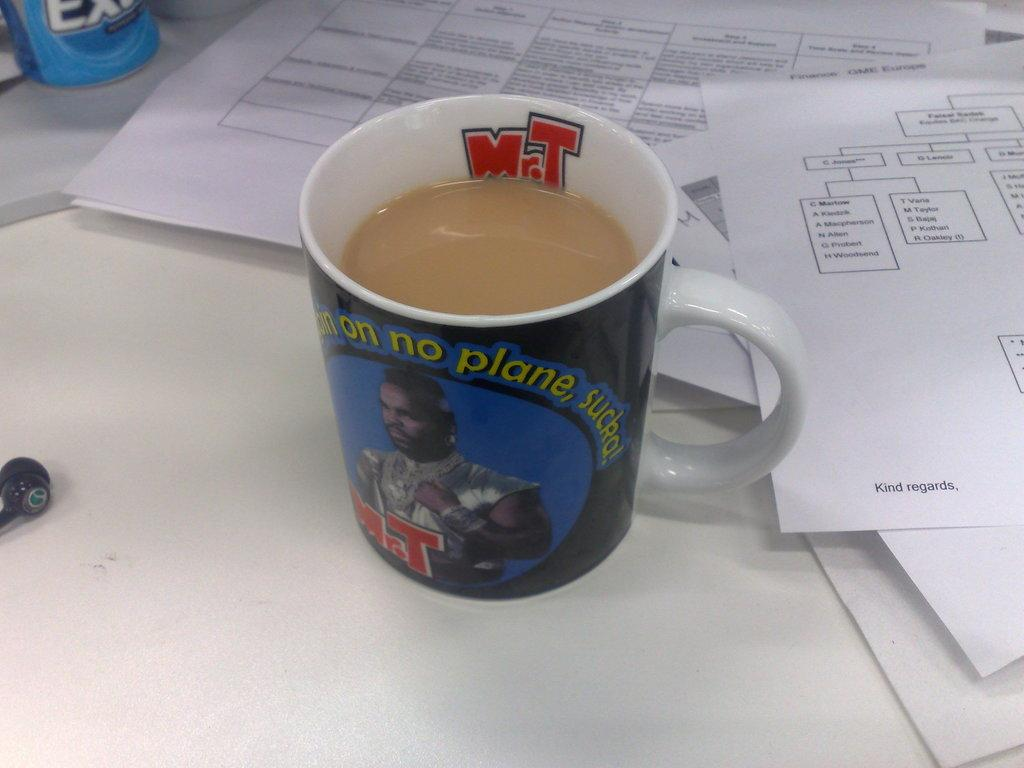<image>
Write a terse but informative summary of the picture. A mug is on a desk with papers on it that say Kind regards. 